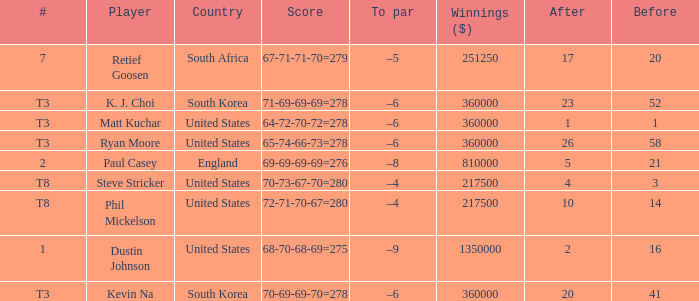What is the score when the player is Matt Kuchar? 64-72-70-72=278. Write the full table. {'header': ['#', 'Player', 'Country', 'Score', 'To par', 'Winnings ($)', 'After', 'Before'], 'rows': [['7', 'Retief Goosen', 'South Africa', '67-71-71-70=279', '–5', '251250', '17', '20'], ['T3', 'K. J. Choi', 'South Korea', '71-69-69-69=278', '–6', '360000', '23', '52'], ['T3', 'Matt Kuchar', 'United States', '64-72-70-72=278', '–6', '360000', '1', '1'], ['T3', 'Ryan Moore', 'United States', '65-74-66-73=278', '–6', '360000', '26', '58'], ['2', 'Paul Casey', 'England', '69-69-69-69=276', '–8', '810000', '5', '21'], ['T8', 'Steve Stricker', 'United States', '70-73-67-70=280', '–4', '217500', '4', '3'], ['T8', 'Phil Mickelson', 'United States', '72-71-70-67=280', '–4', '217500', '10', '14'], ['1', 'Dustin Johnson', 'United States', '68-70-68-69=275', '–9', '1350000', '2', '16'], ['T3', 'Kevin Na', 'South Korea', '70-69-69-70=278', '–6', '360000', '20', '41']]} 